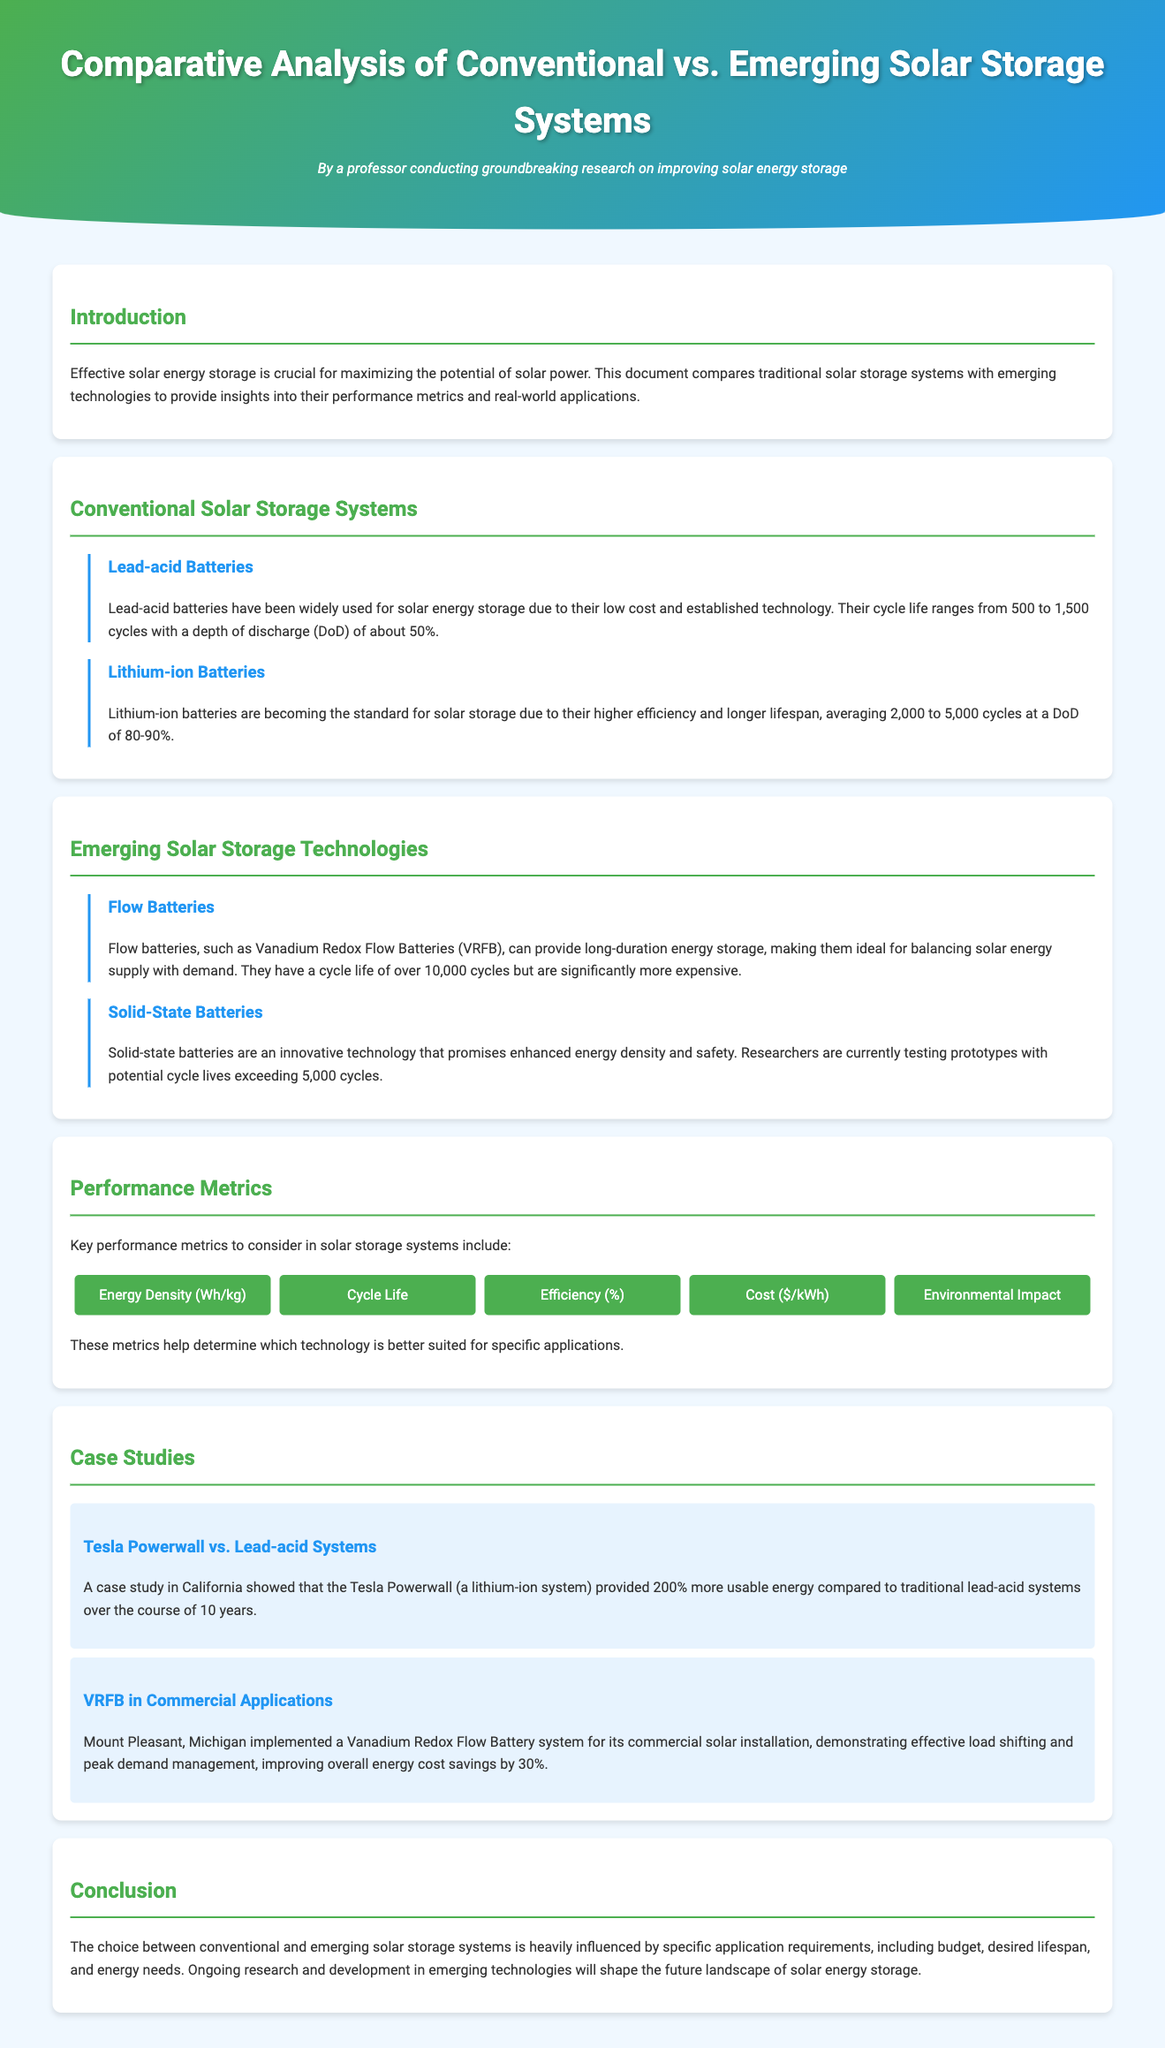What is the cycle life range for lead-acid batteries? Lead-acid batteries have a cycle life ranging from 500 to 1,500 cycles.
Answer: 500 to 1,500 cycles What is the depth of discharge for lithium-ion batteries? Lithium-ion batteries have a depth of discharge (DoD) of 80-90%.
Answer: 80-90% What is the cycle life for Vanadium Redox Flow Batteries? Flow batteries, such as Vanadium Redox Flow Batteries (VRFB), have a cycle life of over 10,000 cycles.
Answer: Over 10,000 cycles What are the key performance metrics listed? The document lists energy density, cycle life, efficiency, cost, and environmental impact as key performance metrics.
Answer: Energy density, cycle life, efficiency, cost, environmental impact Which solar storage system is compared with Tesla Powerwall in the case study? The case study compares Tesla Powerwall with traditional lead-acid systems.
Answer: Traditional lead-acid systems Why are solid-state batteries considered innovative? Solid-state batteries are considered innovative due to enhanced energy density and safety.
Answer: Enhanced energy density and safety What improvement in energy cost savings was demonstrated by the VRFB case study? The VRFB case study showed an improvement in energy cost savings by 30%.
Answer: 30% What color scheme is used for the document's header? The header features a background with a gradient of green and blue.
Answer: Gradient of green and blue 